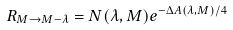Convert formula to latex. <formula><loc_0><loc_0><loc_500><loc_500>R _ { M \to M - \lambda } = N ( \lambda , M ) e ^ { - \Delta A ( \lambda , M ) / 4 }</formula> 